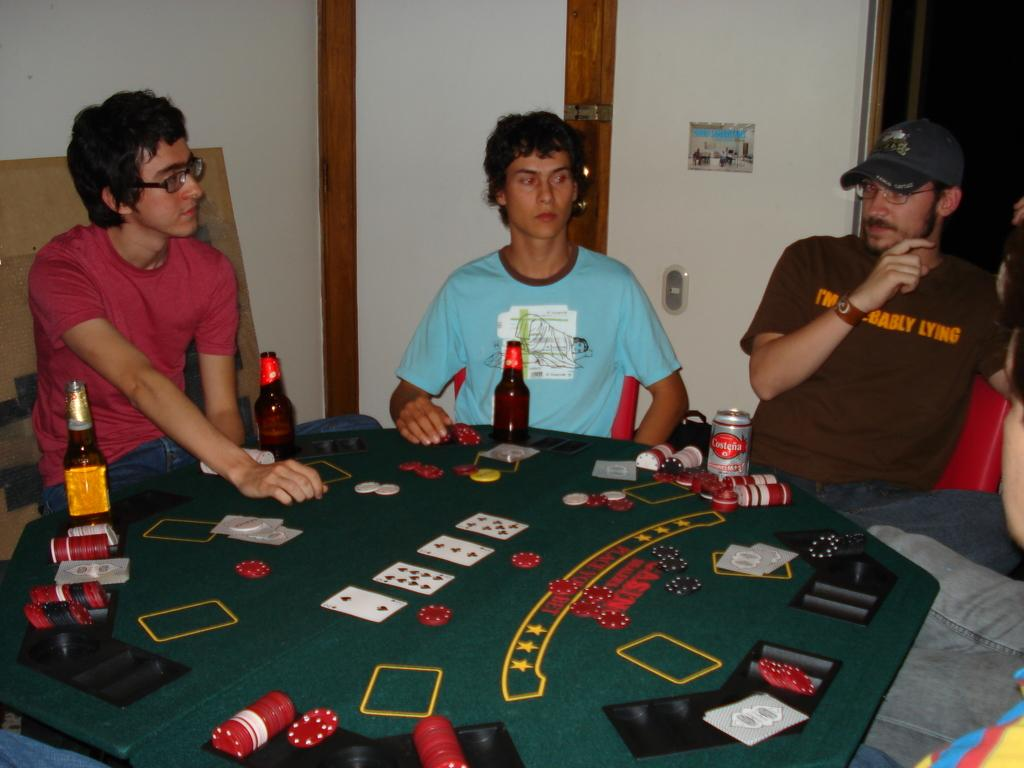How many men are in the image? There are 4 men in the image. What are the men doing in the image? The men are sitting on chairs. How are the chairs arranged in the image? The chairs are arranged around a table. What is on the table in the image? There is a pack of cards, 3 beer bottles, and at least one drink bottle on the table. What type of brick is being used to build the table in the image? There is no brick visible in the image, as the table is already constructed. 